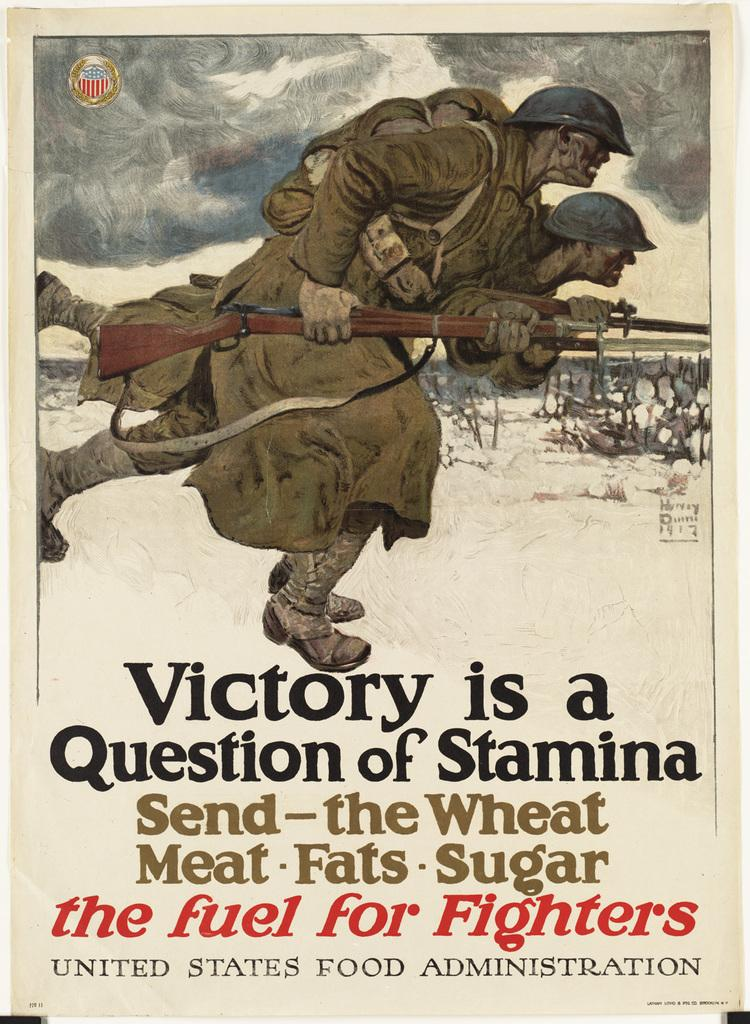<image>
Relay a brief, clear account of the picture shown. A propaganda poster saying that Victory is a Question of Stamina. 